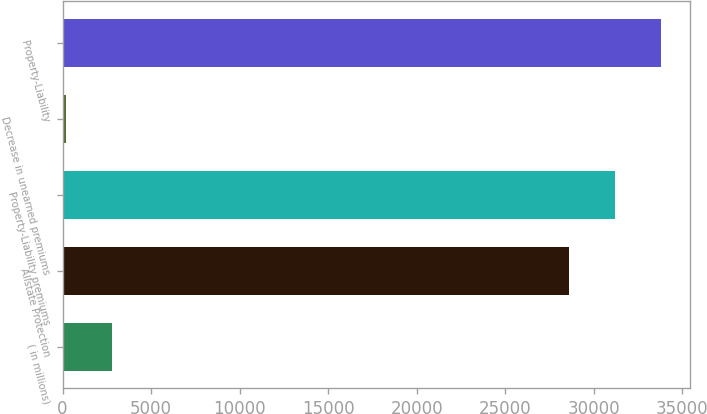<chart> <loc_0><loc_0><loc_500><loc_500><bar_chart><fcel>( in millions)<fcel>Allstate Protection<fcel>Property-Liability premiums<fcel>Decrease in unearned premiums<fcel>Property-Liability<nl><fcel>2799.4<fcel>28570.4<fcel>31169.8<fcel>200<fcel>33769.2<nl></chart> 